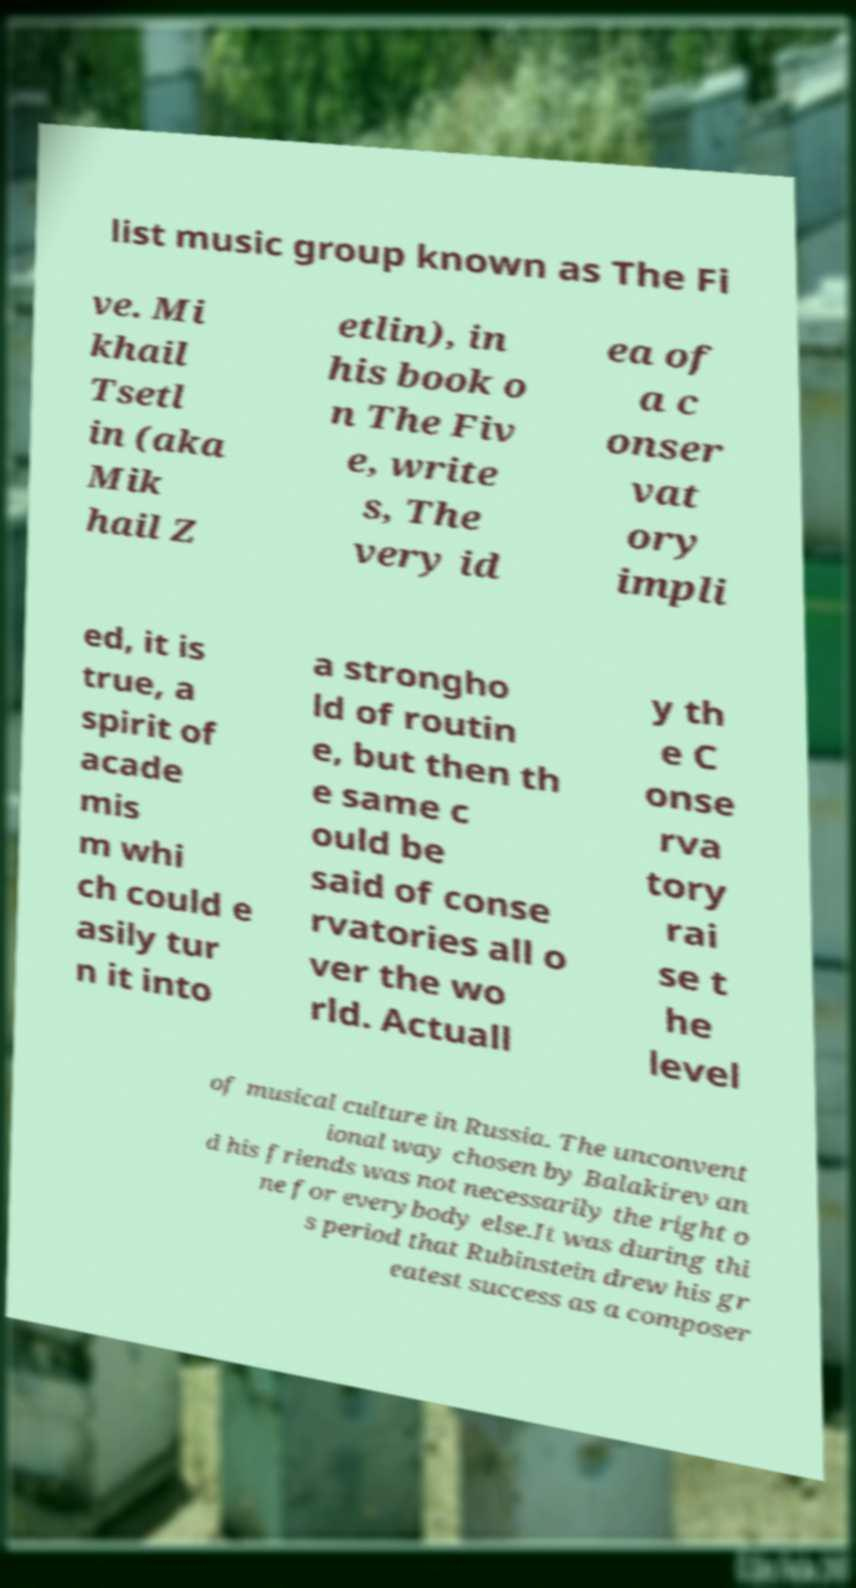There's text embedded in this image that I need extracted. Can you transcribe it verbatim? list music group known as The Fi ve. Mi khail Tsetl in (aka Mik hail Z etlin), in his book o n The Fiv e, write s, The very id ea of a c onser vat ory impli ed, it is true, a spirit of acade mis m whi ch could e asily tur n it into a strongho ld of routin e, but then th e same c ould be said of conse rvatories all o ver the wo rld. Actuall y th e C onse rva tory rai se t he level of musical culture in Russia. The unconvent ional way chosen by Balakirev an d his friends was not necessarily the right o ne for everybody else.It was during thi s period that Rubinstein drew his gr eatest success as a composer 